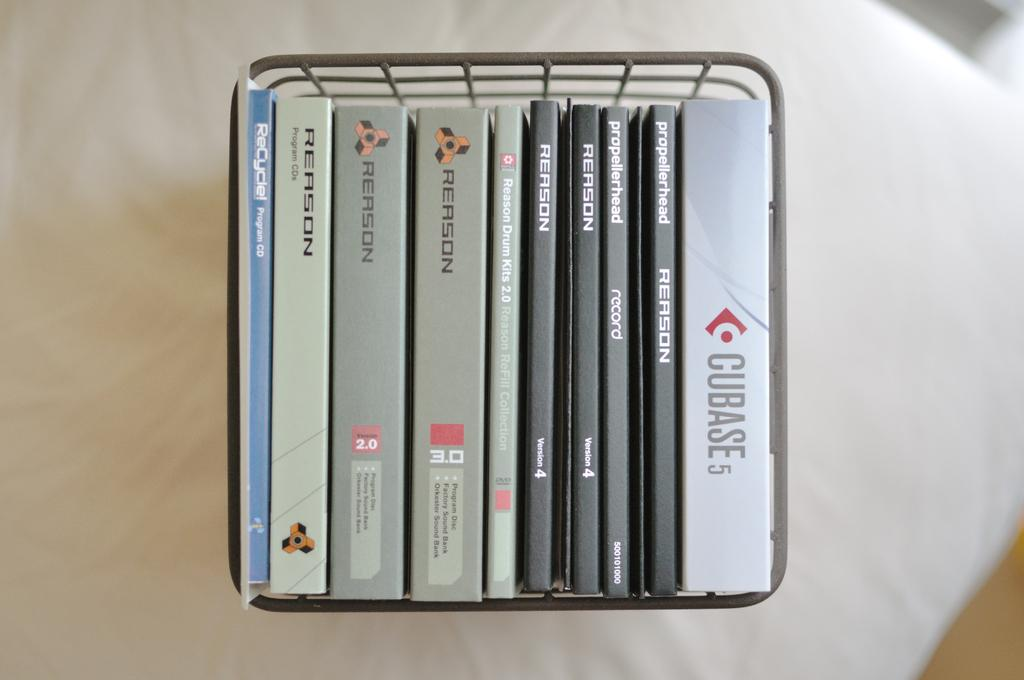<image>
Render a clear and concise summary of the photo. A series of discs are titled CUBASE 5 among others. 